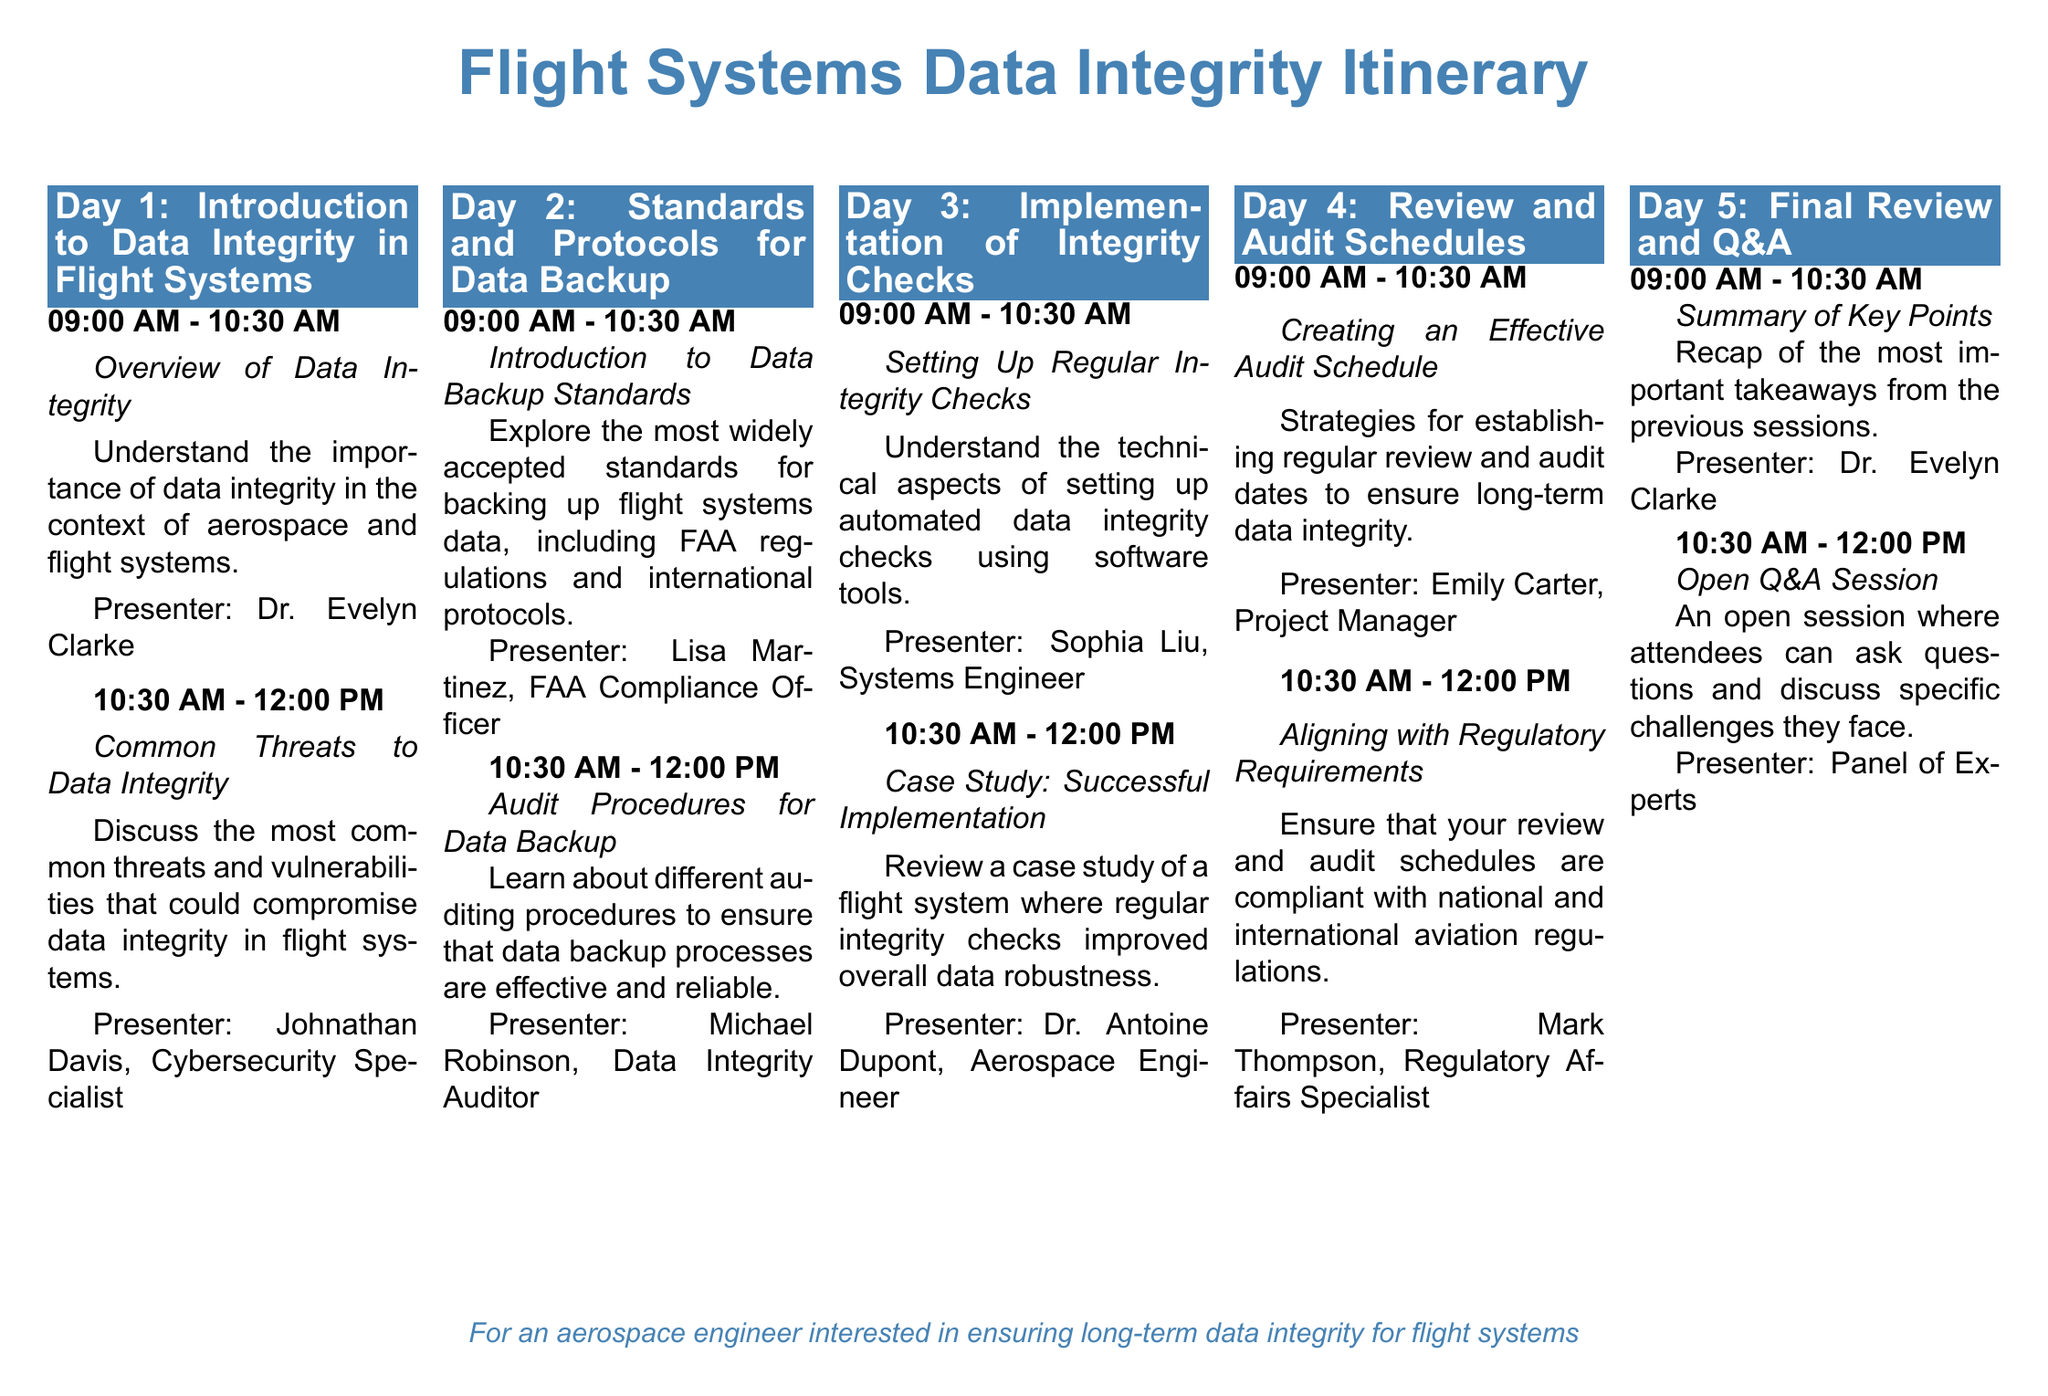What is the title of the first session? The title of the first session is found within the session details under Day 1.
Answer: Overview of Data Integrity Who presented the session on "Aligning with Regulatory Requirements"? The presenter is listed at the end of the session details for Day 4.
Answer: Mark Thompson What time does the "Open Q&A Session" start? The starting time for the "Open Q&A Session" is specified in the Day 5 agenda.
Answer: 10:30 AM How many sessions are scheduled on Day 3? The number of sessions can be determined by counting the sessions listed under Day 3.
Answer: 2 What is the main focus of the session by Sophia Liu? The focus of this session is described in relation to integrity checks.
Answer: Setting Up Regular Integrity Checks What is the main benefit discussed in Dr. Antoine Dupont's session? The benefit is detailed based on the content of the case study reviewed in the session.
Answer: Improved overall data robustness What should be considered when creating an audit schedule? The considerations are implied in the session details for creating effective schedules.
Answer: Regular review and audit dates What overall theme does the itinerary address? The theme can be summarized based on the title and session content throughout the document.
Answer: Flight Systems Data Integrity 